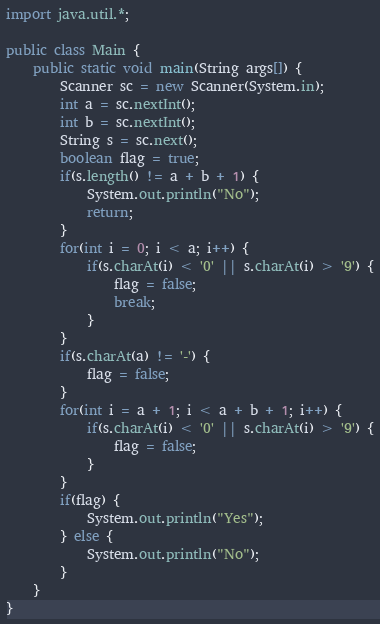<code> <loc_0><loc_0><loc_500><loc_500><_Java_>import java.util.*;

public class Main {
	public static void main(String args[]) {
		Scanner sc = new Scanner(System.in);
		int a = sc.nextInt();
		int b = sc.nextInt();
		String s = sc.next();
		boolean flag = true;
		if(s.length() != a + b + 1) {
			System.out.println("No");
			return;
		}
		for(int i = 0; i < a; i++) {
			if(s.charAt(i) < '0' || s.charAt(i) > '9') {
				flag = false;
				break;
			}
		}
		if(s.charAt(a) != '-') {
			flag = false;
		}
		for(int i = a + 1; i < a + b + 1; i++) {
			if(s.charAt(i) < '0' || s.charAt(i) > '9') {
				flag = false;
			}
		}
		if(flag) {
			System.out.println("Yes");
		} else {
			System.out.println("No");
		}
	}
}</code> 